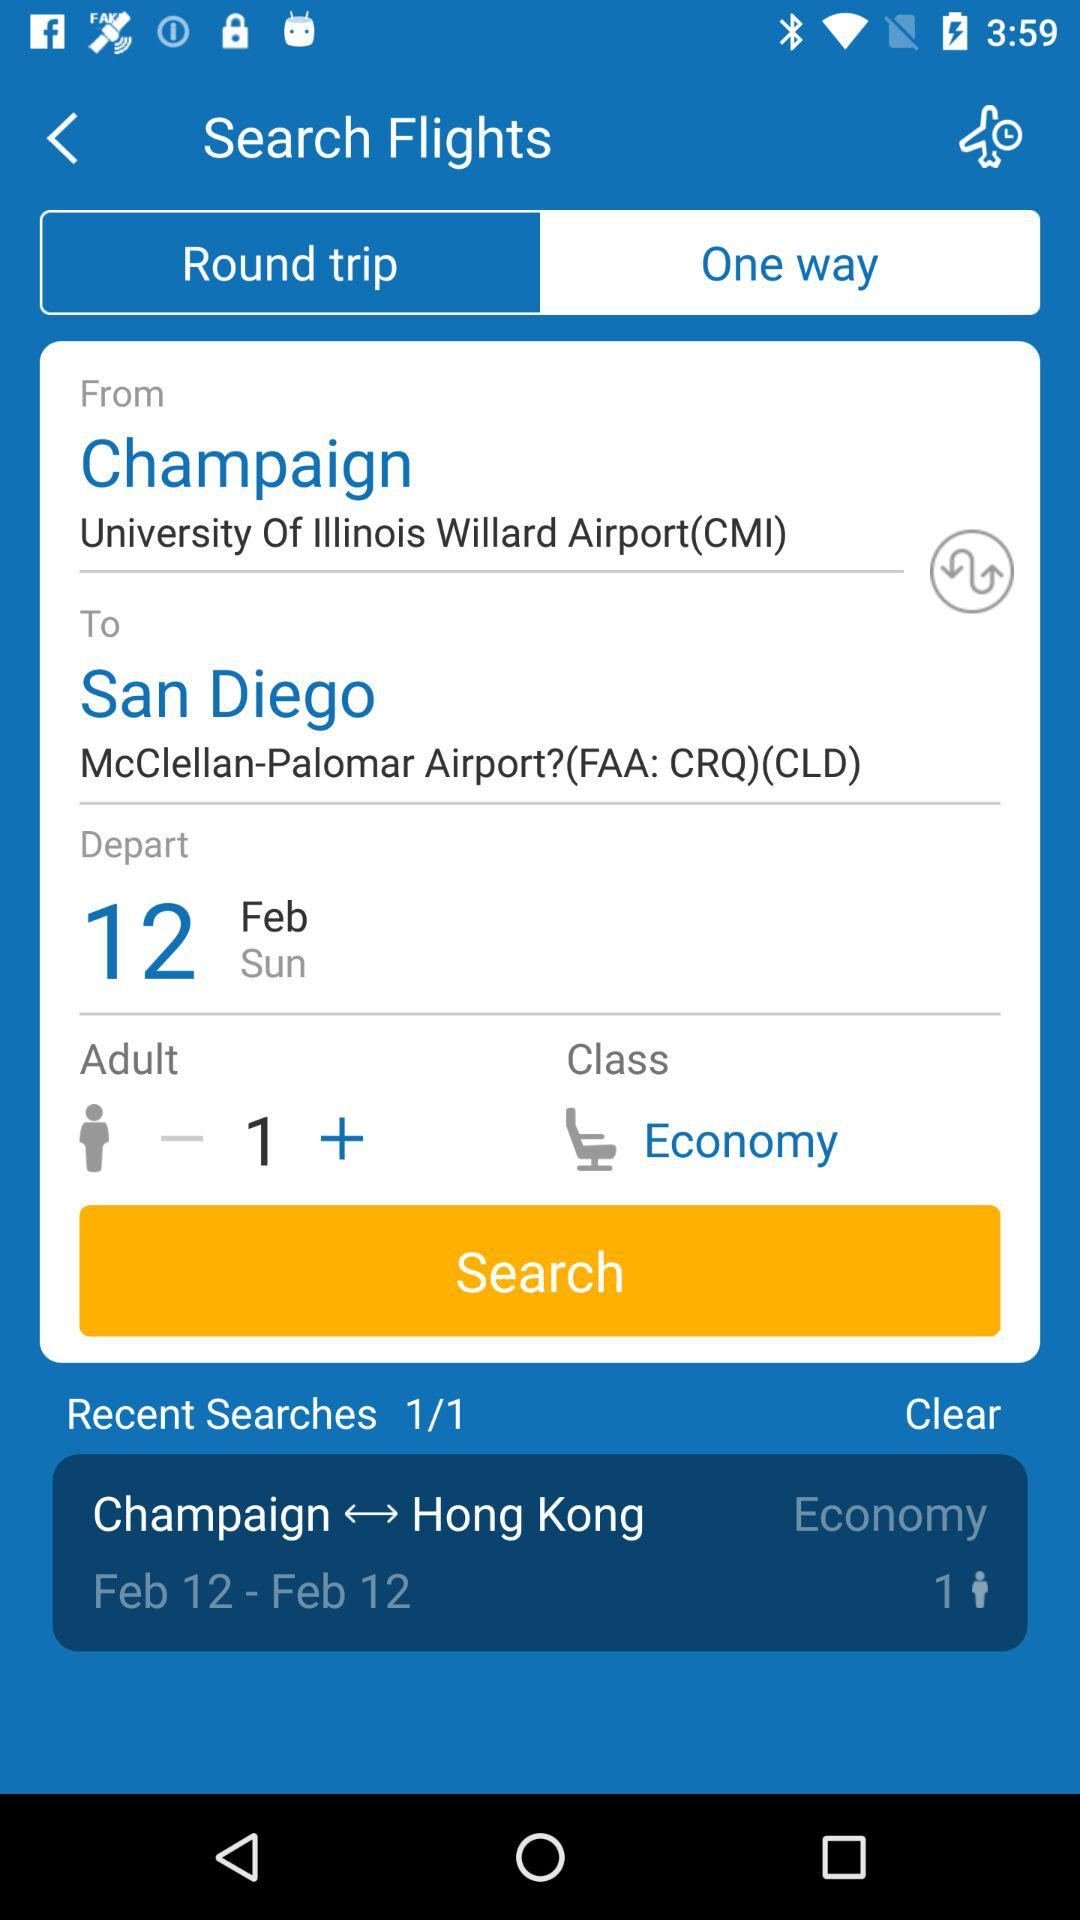How many people are flying?
Answer the question using a single word or phrase. 1 